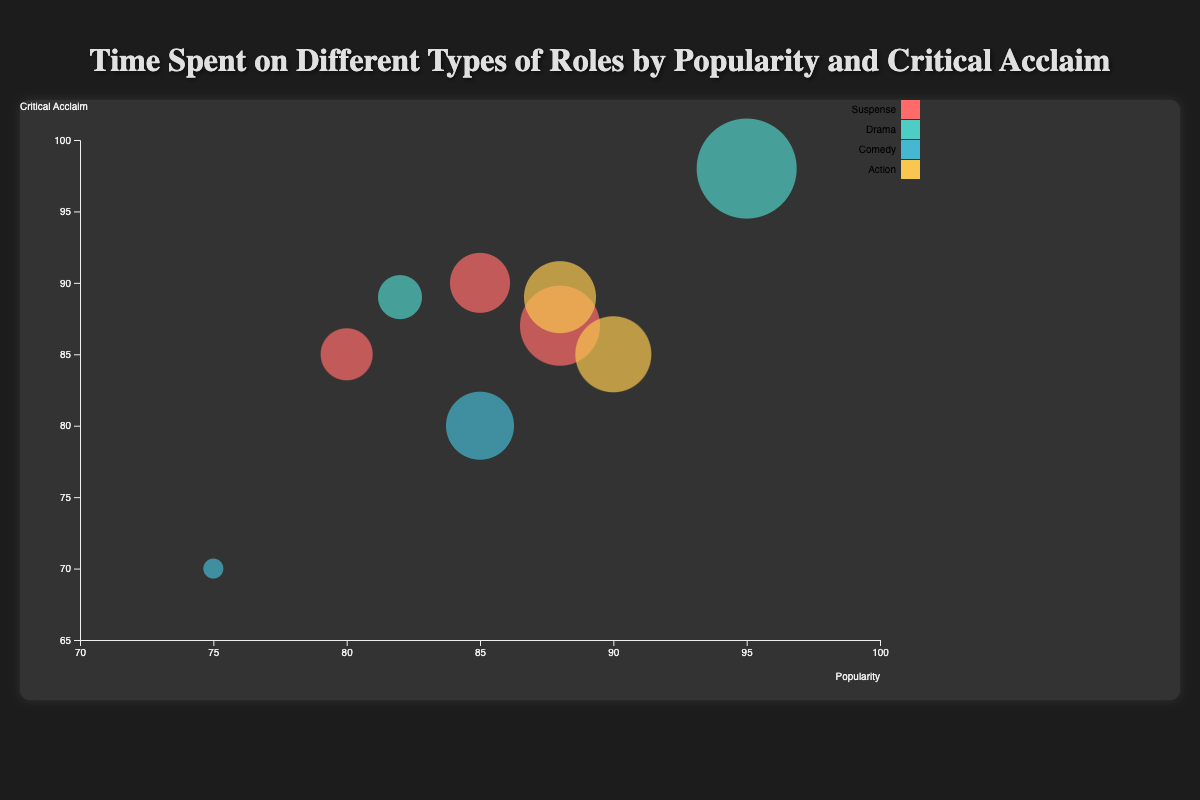what is the title of the chart? The title of the chart is displayed at the top of the figure, which reads "Time Spent on Different Types of Roles by Popularity and Critical Acclaim".
Answer: Time Spent on Different Types of Roles by Popularity and Critical Acclaim What are the axes labels on the chart? The x-axis is labeled "Popularity" and the y-axis is labeled "Critical Acclaim".
Answer: Popularity, Critical Acclaim Which role type has the highest average critical acclaim? To find this, calculate the average critical acclaim for each role type. For Suspense: (90 + 85 + 87)/3 = 87.33. For Drama: (98 + 89)/2 = 93.5. For Comedy: (70 + 80)/2 = 75. For Action: (85 + 89)/2 = 87. Drama has the highest average critical acclaim.
Answer: Drama How many actresses are represented in the figure? By counting the data points or the number of different actresses' names mentioned, we find there are 9 actresses.
Answer: 9 What is the color representation for the Comedy role type? By looking at the legend on the chart, the color representing the Comedy role type is a shade of blue.
Answer: Blue Which actress has spent the most time in their roles? To determine this, look for the largest bubble which represents the most time spent. Meryl Streep has the largest bubble with 400 hours spent.
Answer: Meryl Streep How much more popular is Scarlett Johansson compared to Melissa McCarthy? Scarlett Johansson has a popularity score of 90, while Melissa McCarthy has a score of 75. The difference is 90 - 75.
Answer: 15 Which role type has the widest range of time spent on roles? Calculate the range for each role type: Suspense (350 - 280 = 70), Drama (400 - 260 = 140), Comedy (320 - 200 = 120), Action (340 - 330 = 10). Drama has the widest range of time spent on roles.
Answer: Drama Which actress has the highest combination of popularity and critical acclaim scores? Sum the popularity and critical acclaim scores for each actress. The highest sum is for Meryl Streep with 95 + 98 = 193.
Answer: Meryl Streep 